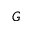Convert formula to latex. <formula><loc_0><loc_0><loc_500><loc_500>G</formula> 